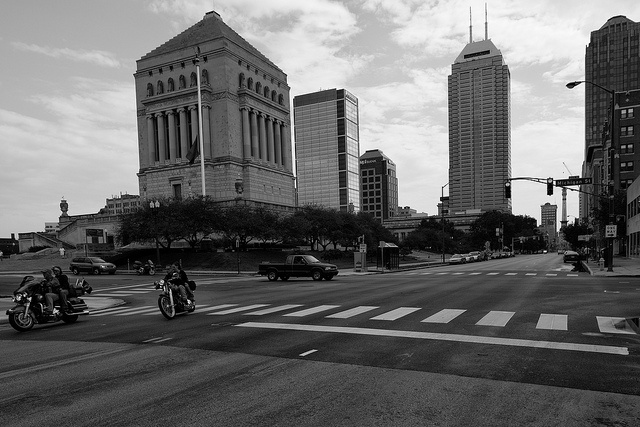Describe the objects in this image and their specific colors. I can see motorcycle in darkgray, black, gray, and lightgray tones, motorcycle in darkgray, black, gray, and lightgray tones, truck in darkgray, black, gray, and lightgray tones, car in darkgray, black, gray, and lightgray tones, and people in black, gray, and darkgray tones in this image. 